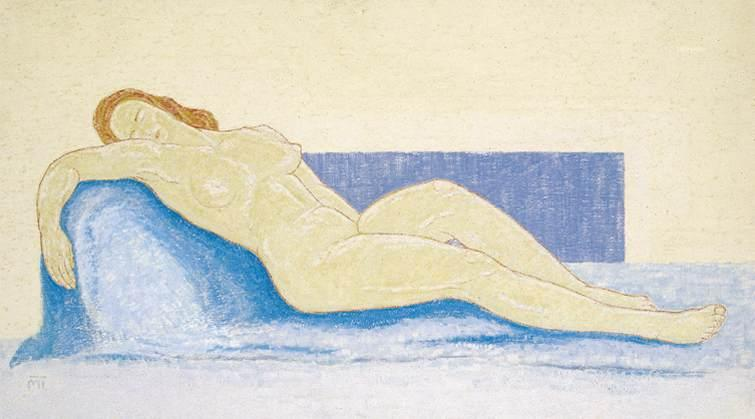Write a detailed description of the given image. The image features an evocative pastel drawing of a reclining nude female figure, positioned languidly on a bright blue couch. Her head rests on her arm, an indication of deep relaxation or slumber. This intimate scene is set against a subtly textured, pale yellow background, with a distinct rectangular blue backdrop behind the couch, adding a geometric contrast to the organic forms. The artist employs a soft pastel palette, masterfully capturing the curves and relaxed posture of the figure. The delicate interplay of colors and the gentle rendering of the figure’s skin tones highlight the tranquility and vulnerability of the subject. This artwork, executed in an impressionistic style, not only depicts the serene moment but also evokes a sense of calm and introspection. 